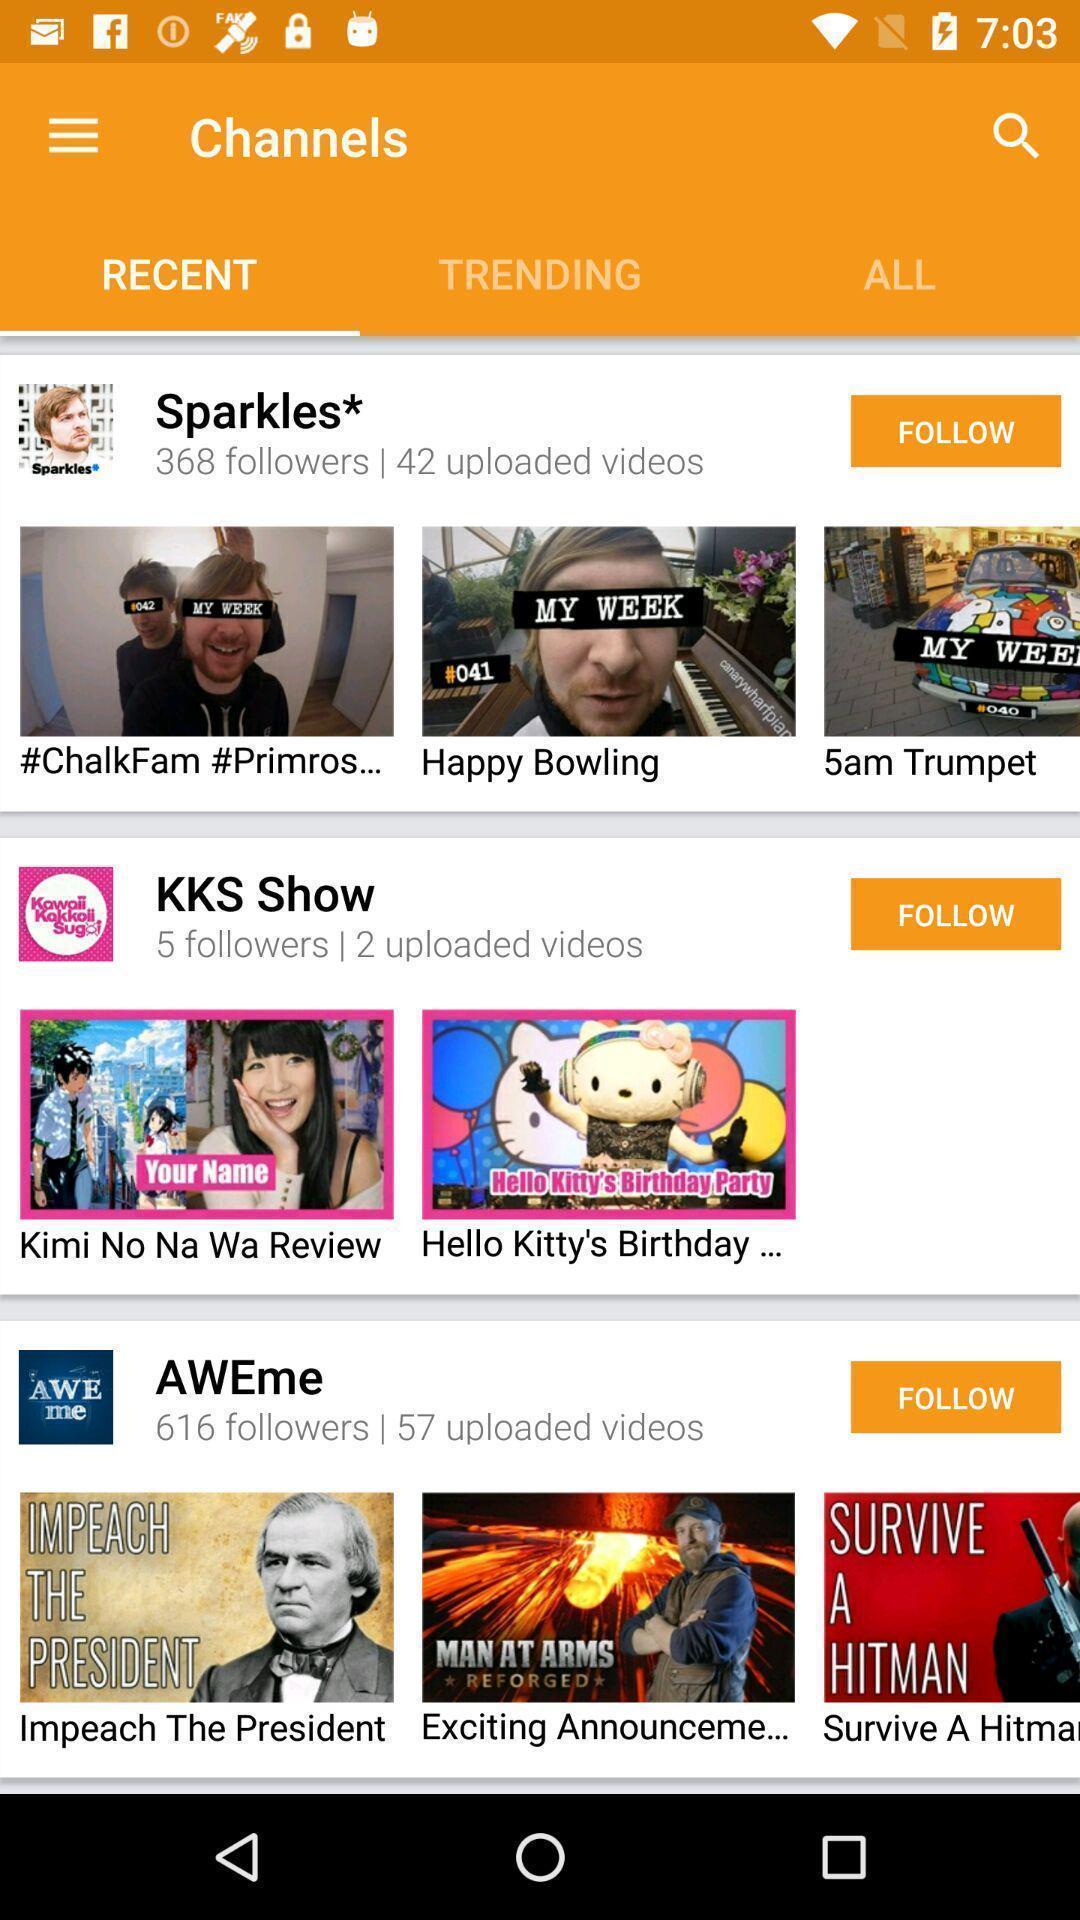Give me a narrative description of this picture. Screen displaying a list of multiple videos. 